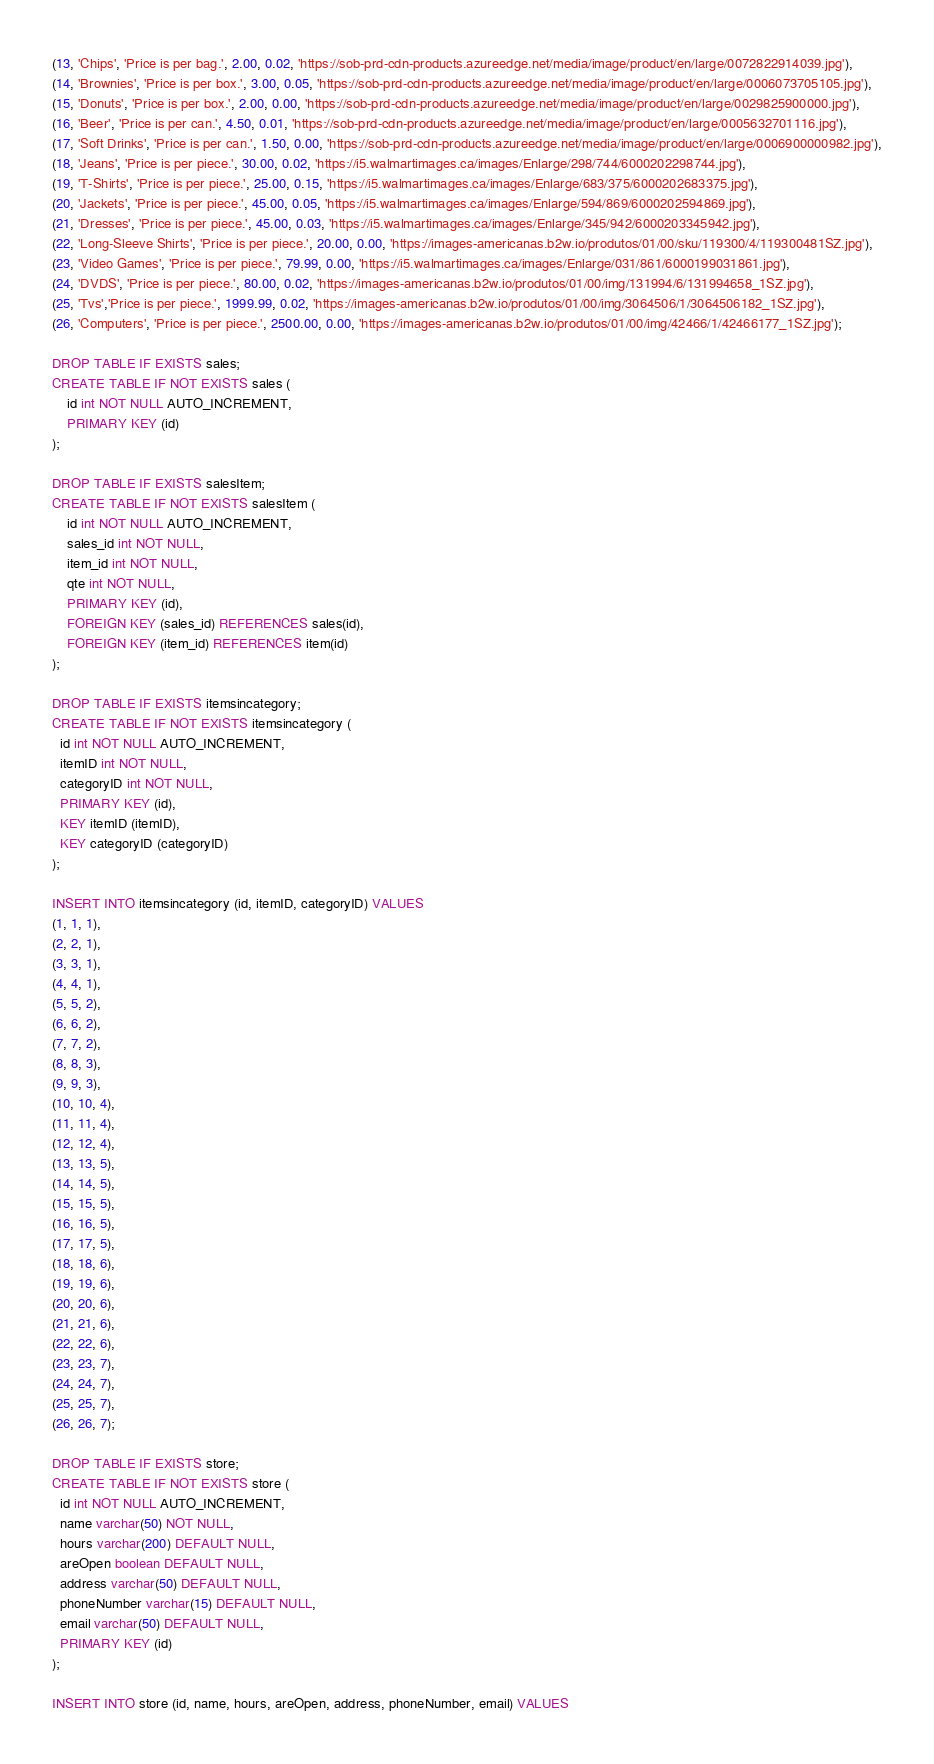Convert code to text. <code><loc_0><loc_0><loc_500><loc_500><_SQL_>(13, 'Chips', 'Price is per bag.', 2.00, 0.02, 'https://sob-prd-cdn-products.azureedge.net/media/image/product/en/large/0072822914039.jpg'),
(14, 'Brownies', 'Price is per box.', 3.00, 0.05, 'https://sob-prd-cdn-products.azureedge.net/media/image/product/en/large/0006073705105.jpg'),
(15, 'Donuts', 'Price is per box.', 2.00, 0.00, 'https://sob-prd-cdn-products.azureedge.net/media/image/product/en/large/0029825900000.jpg'),
(16, 'Beer', 'Price is per can.', 4.50, 0.01, 'https://sob-prd-cdn-products.azureedge.net/media/image/product/en/large/0005632701116.jpg'),
(17, 'Soft Drinks', 'Price is per can.', 1.50, 0.00, 'https://sob-prd-cdn-products.azureedge.net/media/image/product/en/large/0006900000982.jpg'),
(18, 'Jeans', 'Price is per piece.', 30.00, 0.02, 'https://i5.walmartimages.ca/images/Enlarge/298/744/6000202298744.jpg'),
(19, 'T-Shirts', 'Price is per piece.', 25.00, 0.15, 'https://i5.walmartimages.ca/images/Enlarge/683/375/6000202683375.jpg'),
(20, 'Jackets', 'Price is per piece.', 45.00, 0.05, 'https://i5.walmartimages.ca/images/Enlarge/594/869/6000202594869.jpg'),
(21, 'Dresses', 'Price is per piece.', 45.00, 0.03, 'https://i5.walmartimages.ca/images/Enlarge/345/942/6000203345942.jpg'),
(22, 'Long-Sleeve Shirts', 'Price is per piece.', 20.00, 0.00, 'https://images-americanas.b2w.io/produtos/01/00/sku/119300/4/119300481SZ.jpg'),
(23, 'Video Games', 'Price is per piece.', 79.99, 0.00, 'https://i5.walmartimages.ca/images/Enlarge/031/861/6000199031861.jpg'),
(24, 'DVDS', 'Price is per piece.', 80.00, 0.02, 'https://images-americanas.b2w.io/produtos/01/00/img/131994/6/131994658_1SZ.jpg'),
(25, 'Tvs','Price is per piece.', 1999.99, 0.02, 'https://images-americanas.b2w.io/produtos/01/00/img/3064506/1/3064506182_1SZ.jpg'),
(26, 'Computers', 'Price is per piece.', 2500.00, 0.00, 'https://images-americanas.b2w.io/produtos/01/00/img/42466/1/42466177_1SZ.jpg');

DROP TABLE IF EXISTS sales;
CREATE TABLE IF NOT EXISTS sales (
    id int NOT NULL AUTO_INCREMENT,
    PRIMARY KEY (id)
);

DROP TABLE IF EXISTS salesItem;
CREATE TABLE IF NOT EXISTS salesItem (
    id int NOT NULL AUTO_INCREMENT,
    sales_id int NOT NULL,
    item_id int NOT NULL,
    qte int NOT NULL,
    PRIMARY KEY (id),
    FOREIGN KEY (sales_id) REFERENCES sales(id),
    FOREIGN KEY (item_id) REFERENCES item(id)
);

DROP TABLE IF EXISTS itemsincategory;
CREATE TABLE IF NOT EXISTS itemsincategory (
  id int NOT NULL AUTO_INCREMENT,
  itemID int NOT NULL,
  categoryID int NOT NULL,
  PRIMARY KEY (id),
  KEY itemID (itemID),
  KEY categoryID (categoryID)
);

INSERT INTO itemsincategory (id, itemID, categoryID) VALUES
(1, 1, 1),
(2, 2, 1),
(3, 3, 1),
(4, 4, 1),
(5, 5, 2),
(6, 6, 2),
(7, 7, 2),
(8, 8, 3),
(9, 9, 3),
(10, 10, 4),
(11, 11, 4),
(12, 12, 4),
(13, 13, 5),
(14, 14, 5),
(15, 15, 5),
(16, 16, 5),
(17, 17, 5),
(18, 18, 6),
(19, 19, 6),
(20, 20, 6),
(21, 21, 6),
(22, 22, 6),
(23, 23, 7),
(24, 24, 7),
(25, 25, 7),
(26, 26, 7);

DROP TABLE IF EXISTS store;
CREATE TABLE IF NOT EXISTS store (
  id int NOT NULL AUTO_INCREMENT,
  name varchar(50) NOT NULL,
  hours varchar(200) DEFAULT NULL,
  areOpen boolean DEFAULT NULL,
  address varchar(50) DEFAULT NULL,
  phoneNumber varchar(15) DEFAULT NULL,
  email varchar(50) DEFAULT NULL,
  PRIMARY KEY (id)
);

INSERT INTO store (id, name, hours, areOpen, address, phoneNumber, email) VALUES</code> 